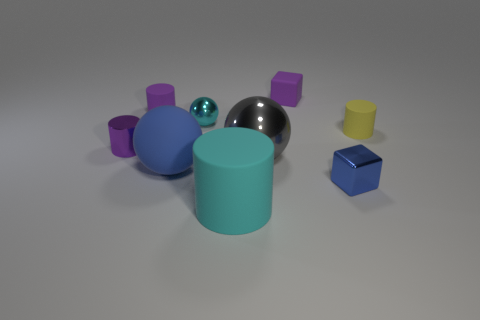Subtract all metallic spheres. How many spheres are left? 1 Subtract all red cylinders. Subtract all cyan cubes. How many cylinders are left? 4 Subtract all balls. How many objects are left? 6 Subtract all blue shiny cubes. Subtract all large cylinders. How many objects are left? 7 Add 9 yellow cylinders. How many yellow cylinders are left? 10 Add 1 blue spheres. How many blue spheres exist? 2 Subtract 0 red cubes. How many objects are left? 9 